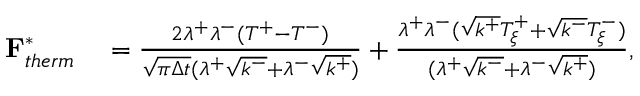Convert formula to latex. <formula><loc_0><loc_0><loc_500><loc_500>\begin{array} { r l } { F _ { t h e r m } ^ { * } } & = \frac { 2 \lambda ^ { + } \lambda ^ { - } ( T ^ { + } - T ^ { - } ) } { \sqrt { \pi \Delta t } ( \lambda ^ { + } \sqrt { k ^ { - } } + \lambda ^ { - } \sqrt { k ^ { + } } ) } + \frac { \lambda ^ { + } \lambda ^ { - } ( \sqrt { k ^ { + } } T _ { \xi } ^ { + } + \sqrt { k ^ { - } } T _ { \xi } ^ { - } ) } { ( \lambda ^ { + } \sqrt { k ^ { - } } + \lambda ^ { - } \sqrt { k ^ { + } } ) } , } \end{array}</formula> 